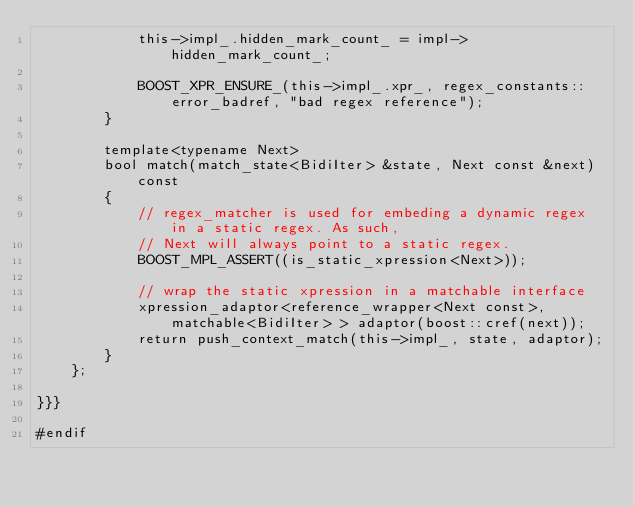<code> <loc_0><loc_0><loc_500><loc_500><_C++_>            this->impl_.hidden_mark_count_ = impl->hidden_mark_count_;

            BOOST_XPR_ENSURE_(this->impl_.xpr_, regex_constants::error_badref, "bad regex reference");
        }

        template<typename Next>
        bool match(match_state<BidiIter> &state, Next const &next) const
        {
            // regex_matcher is used for embeding a dynamic regex in a static regex. As such,
            // Next will always point to a static regex.
            BOOST_MPL_ASSERT((is_static_xpression<Next>));

            // wrap the static xpression in a matchable interface
            xpression_adaptor<reference_wrapper<Next const>, matchable<BidiIter> > adaptor(boost::cref(next));
            return push_context_match(this->impl_, state, adaptor);
        }
    };

}}}

#endif
</code> 